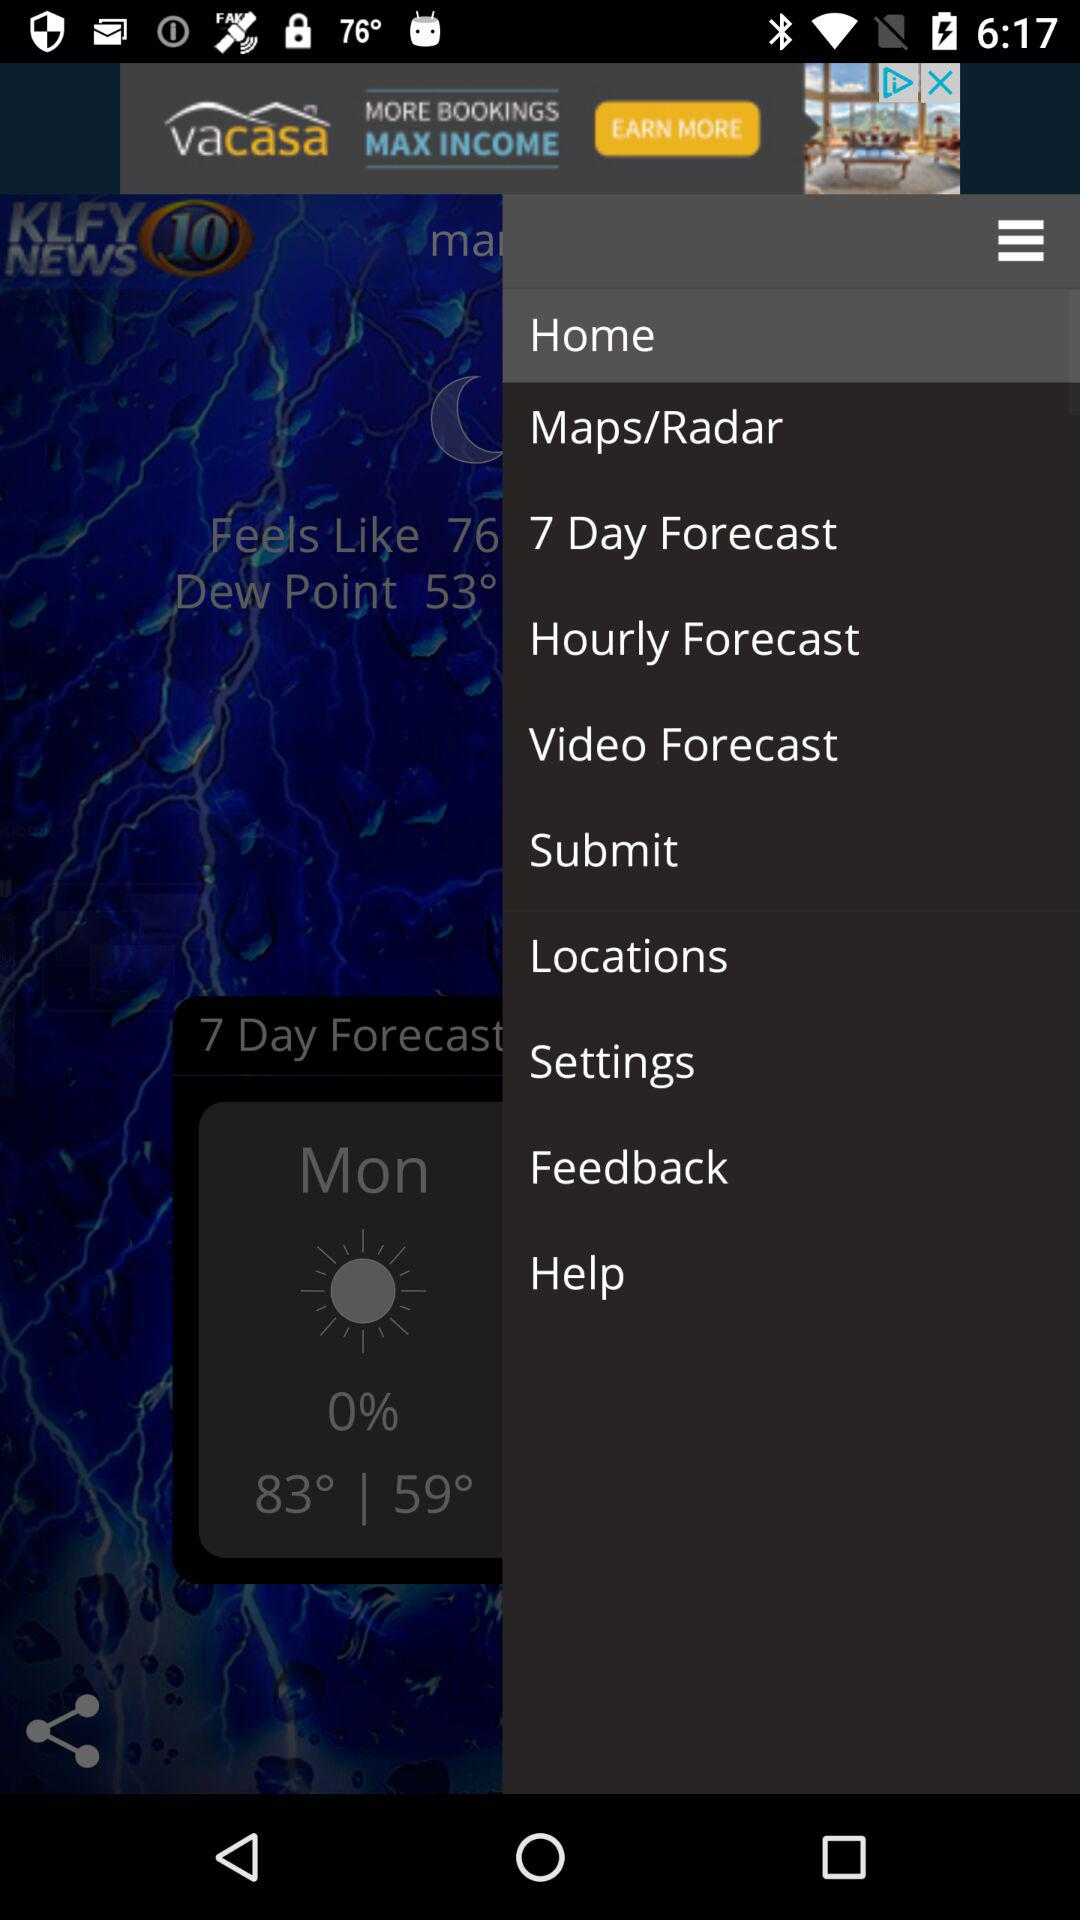How many degrees is the temperature difference between the high and low temperatures?
Answer the question using a single word or phrase. 24 